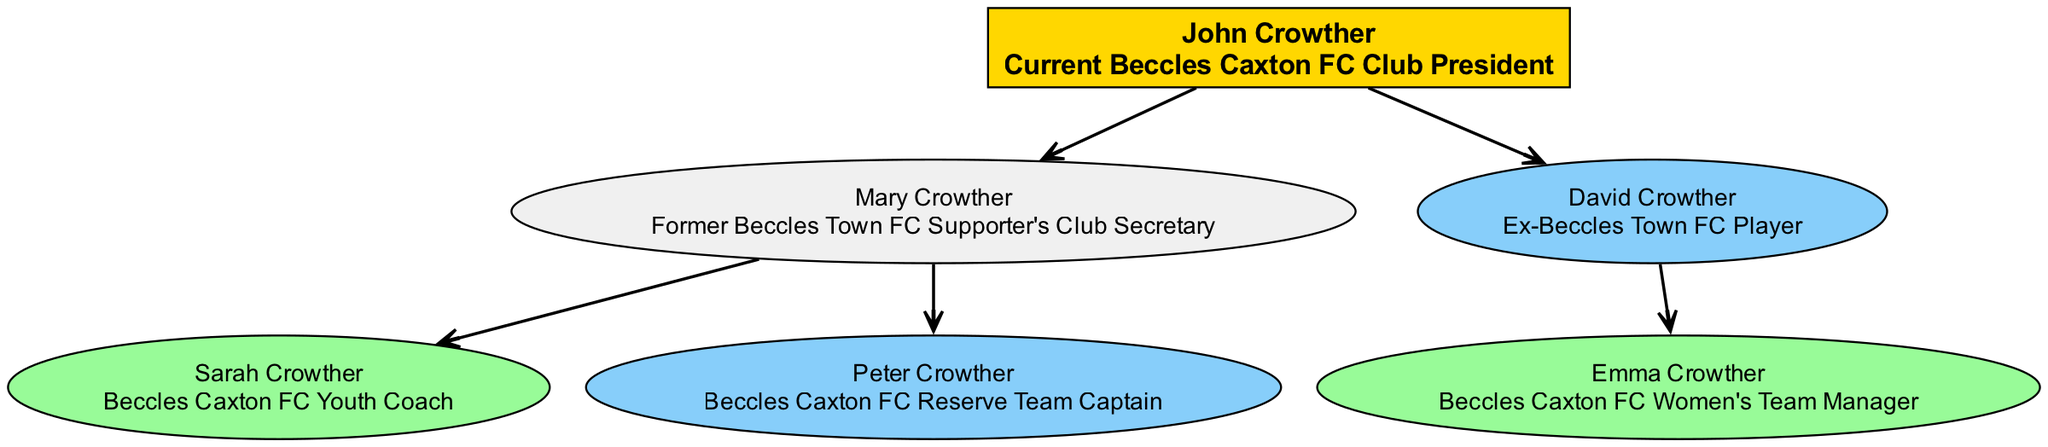What is the name of the current club president? The diagram shows the root node, which is labeled with the name and role of John Crowther as the current Beccles Caxton FC Club President.
Answer: John Crowther How many children does John Crowther have? Upon examining the root node for John Crowther, it can be seen that there are two child nodes: Mary Crowther and David Crowther, indicating that he has two children.
Answer: 2 What role does Mary Crowther hold? By looking at the node for Mary Crowther, it explicitly states her role as the Former Beccles Town FC Supporter's Club Secretary, which is listed below her name.
Answer: Former Beccles Town FC Supporter's Club Secretary Who is the captain of the reserve team? The node for Peter Crowther indicates that he is the Beccles Caxton FC Reserve Team Captain, which can be confirmed upon locating his position in the diagram under Mary Crowther's child nodes.
Answer: Peter Crowther Which member of the Crowther family is involved in women's football? The diagram shows that Emma Crowther is involved as the Beccles Caxton FC Women's Team Manager, which is noted in her respective node under her father David Crowther.
Answer: Emma Crowther What is the relationship between Sarah Crowther and John Crowther? Sarah Crowther is a child of Mary Crowther, who is John Crowther's daughter. Therefore, Sarah is John Crowther's granddaughter.
Answer: Granddaughter Which family member served as an ex-player for Beccles Town FC? The diagram identifies David Crowther as the Ex-Beccles Town FC Player, and it is stated in his node, indicating his involvement in the past.
Answer: David Crowther How is the current club president related to Mary Crowther? The diagram indicates that Mary Crowther is John Crowther's child, as she is labeled under him as one of his children.
Answer: Daughter What color represents the president in the diagram? The node for John Crowther as the president is filled with a golden yellow color (#FFD700), which is attributed to the president role in the diagram.
Answer: Gold 